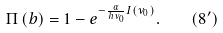<formula> <loc_0><loc_0><loc_500><loc_500>\Pi \left ( b \right ) = 1 - e ^ { - \frac { \alpha } { h \nu _ { 0 } } I ( { \nu _ { 0 } } ) } . \quad ( 8 ^ { \prime } )</formula> 